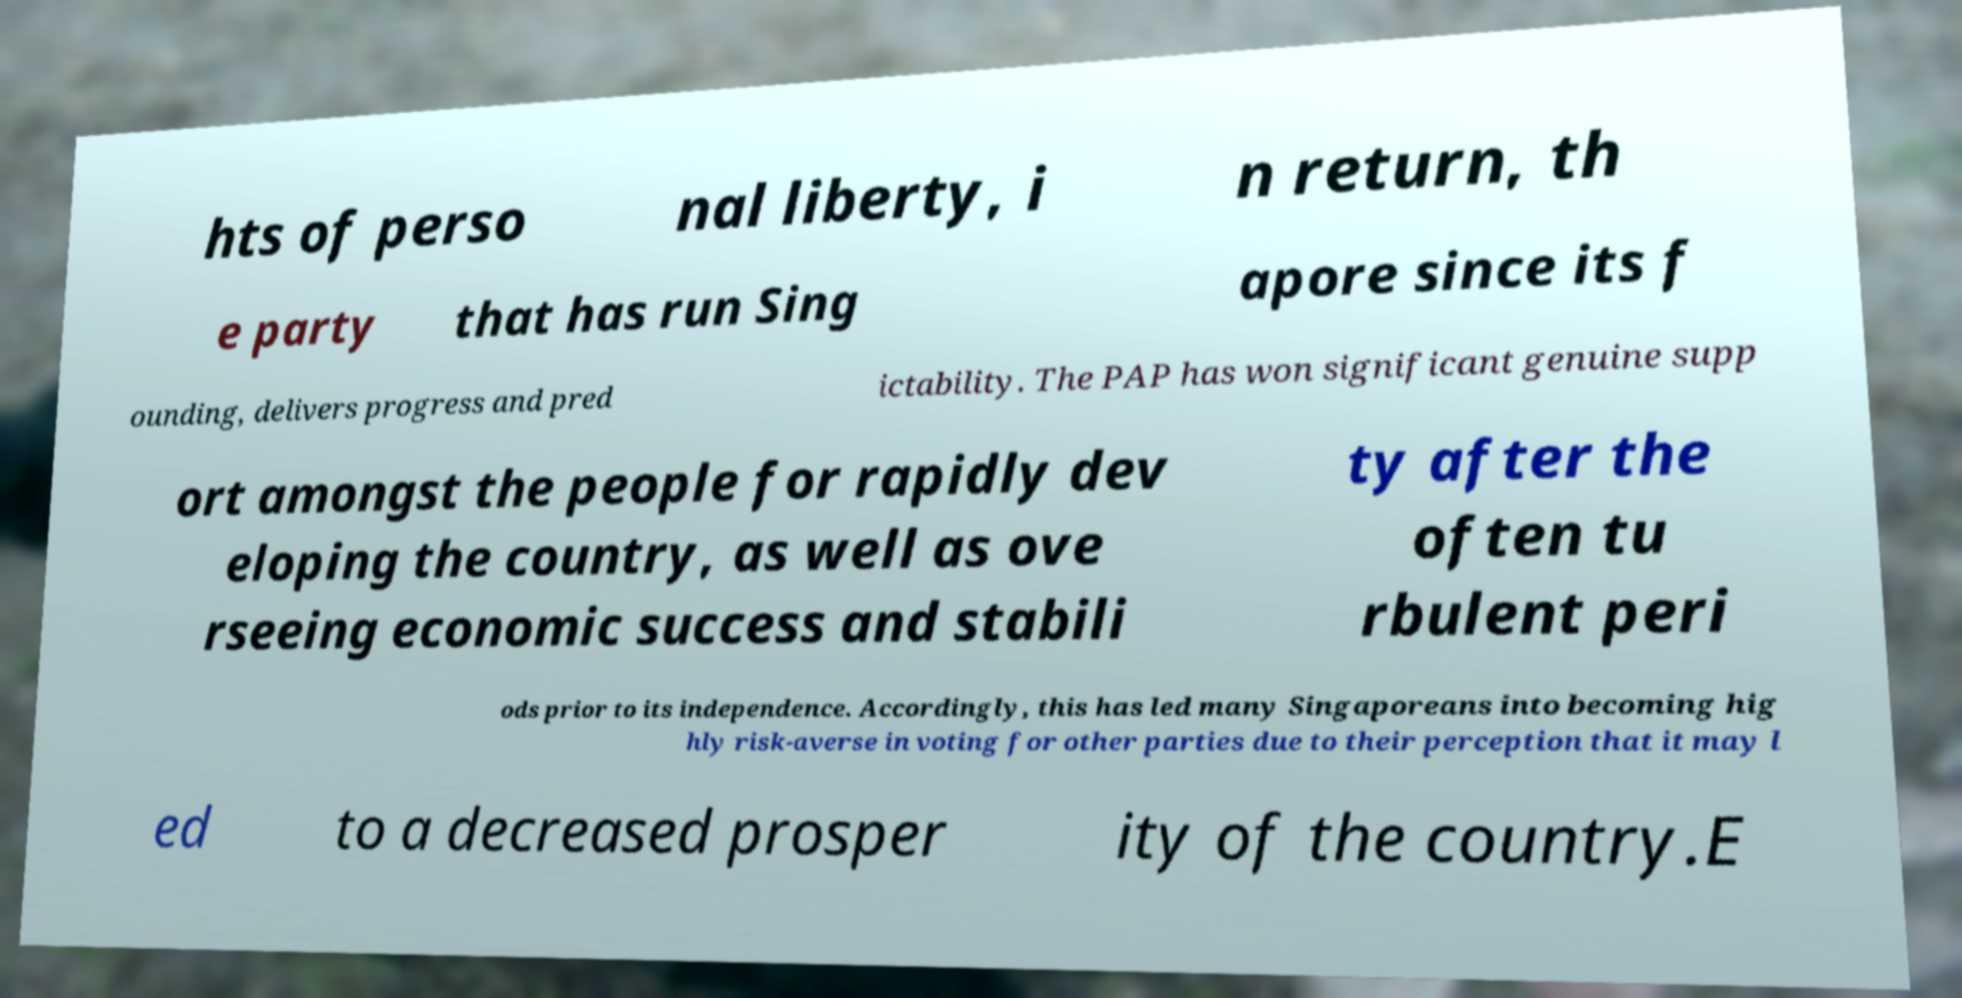There's text embedded in this image that I need extracted. Can you transcribe it verbatim? hts of perso nal liberty, i n return, th e party that has run Sing apore since its f ounding, delivers progress and pred ictability. The PAP has won significant genuine supp ort amongst the people for rapidly dev eloping the country, as well as ove rseeing economic success and stabili ty after the often tu rbulent peri ods prior to its independence. Accordingly, this has led many Singaporeans into becoming hig hly risk-averse in voting for other parties due to their perception that it may l ed to a decreased prosper ity of the country.E 